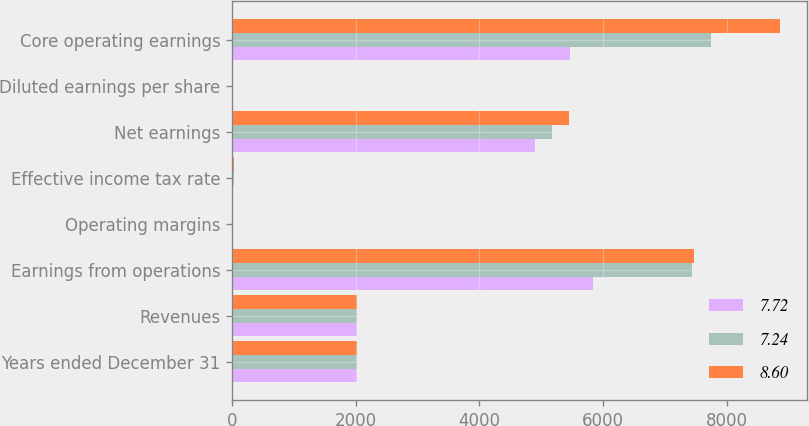<chart> <loc_0><loc_0><loc_500><loc_500><stacked_bar_chart><ecel><fcel>Years ended December 31<fcel>Revenues<fcel>Earnings from operations<fcel>Operating margins<fcel>Effective income tax rate<fcel>Net earnings<fcel>Diluted earnings per share<fcel>Core operating earnings<nl><fcel>7.72<fcel>2016<fcel>2015<fcel>5834<fcel>6.2<fcel>12.1<fcel>4895<fcel>7.61<fcel>5464<nl><fcel>7.24<fcel>2015<fcel>2015<fcel>7443<fcel>7.7<fcel>27.7<fcel>5176<fcel>7.44<fcel>7741<nl><fcel>8.6<fcel>2014<fcel>2015<fcel>7473<fcel>8.2<fcel>23.7<fcel>5446<fcel>7.38<fcel>8860<nl></chart> 